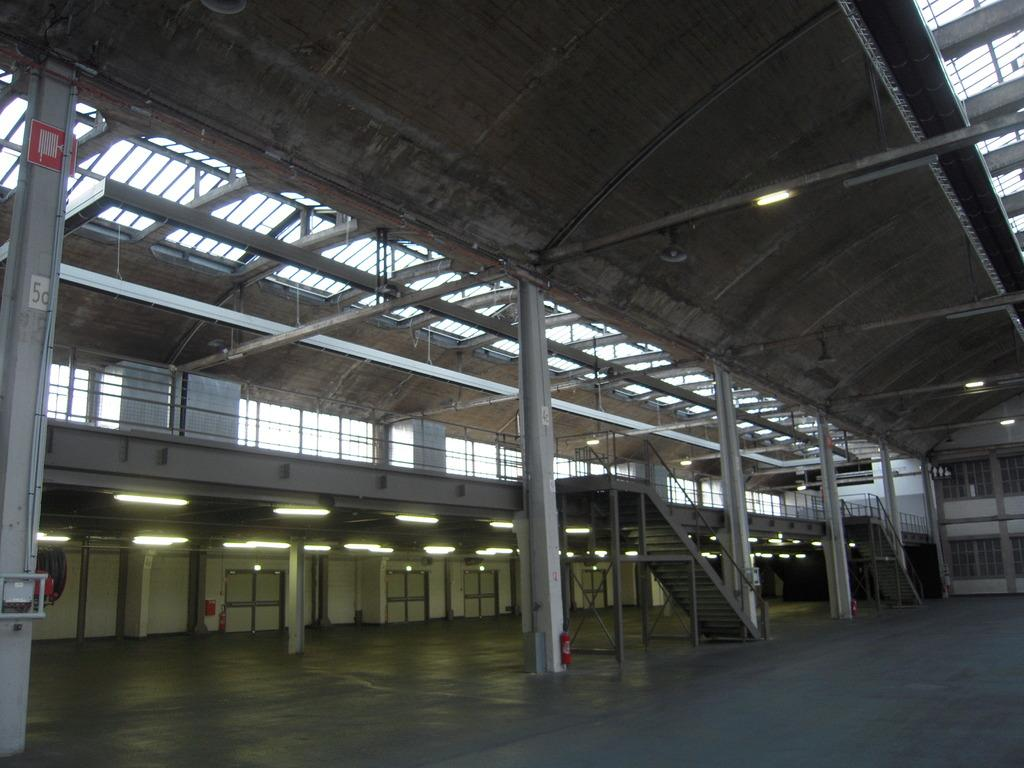What is the main architectural feature in the center of the image? There are stairs in the center of the image. What other structural elements can be seen in the image? There are pillars, windows, doors, and a wall in the image. What type of engine is powering the building in the image? There is no engine present in the image, as it is a building with stairs, pillars, windows, doors, and a wall. 